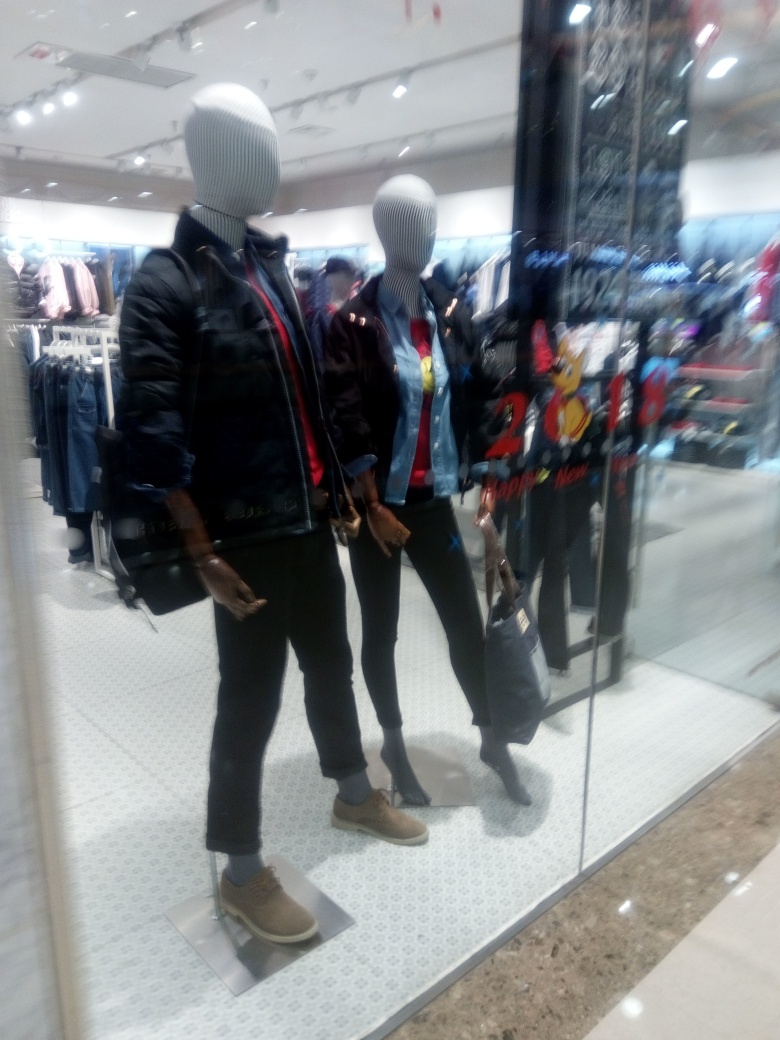Can you describe the clothing displayed on the mannequins? Certainly! The mannequin on the left is dressed in a black jacket with a ribbed design on the shoulders, a white undershirt, dark slacks, and brown shoes, accessorized with a dark handbag. The mannequin on the right is sporting a denim jacket layered over a red t-shirt with a cartoon graphic, paired with dark jeans and beige lace-up boots. 